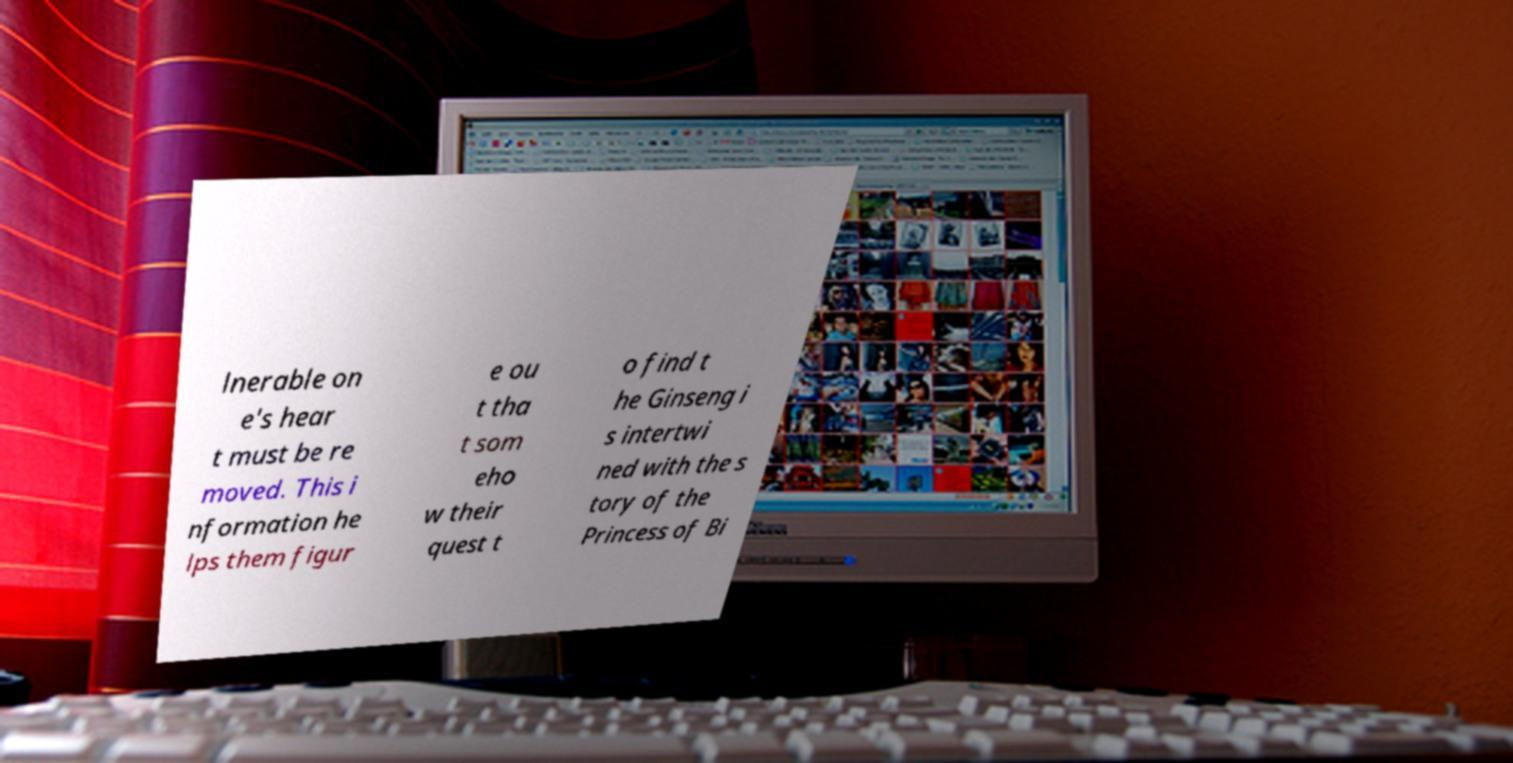Please identify and transcribe the text found in this image. lnerable on e's hear t must be re moved. This i nformation he lps them figur e ou t tha t som eho w their quest t o find t he Ginseng i s intertwi ned with the s tory of the Princess of Bi 